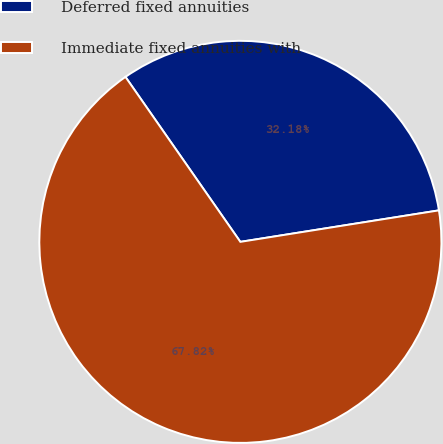Convert chart to OTSL. <chart><loc_0><loc_0><loc_500><loc_500><pie_chart><fcel>Deferred fixed annuities<fcel>Immediate fixed annuities with<nl><fcel>32.18%<fcel>67.82%<nl></chart> 